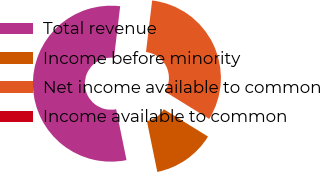<chart> <loc_0><loc_0><loc_500><loc_500><pie_chart><fcel>Total revenue<fcel>Income before minority<fcel>Net income available to common<fcel>Income available to common<nl><fcel>55.1%<fcel>12.97%<fcel>31.92%<fcel>0.0%<nl></chart> 